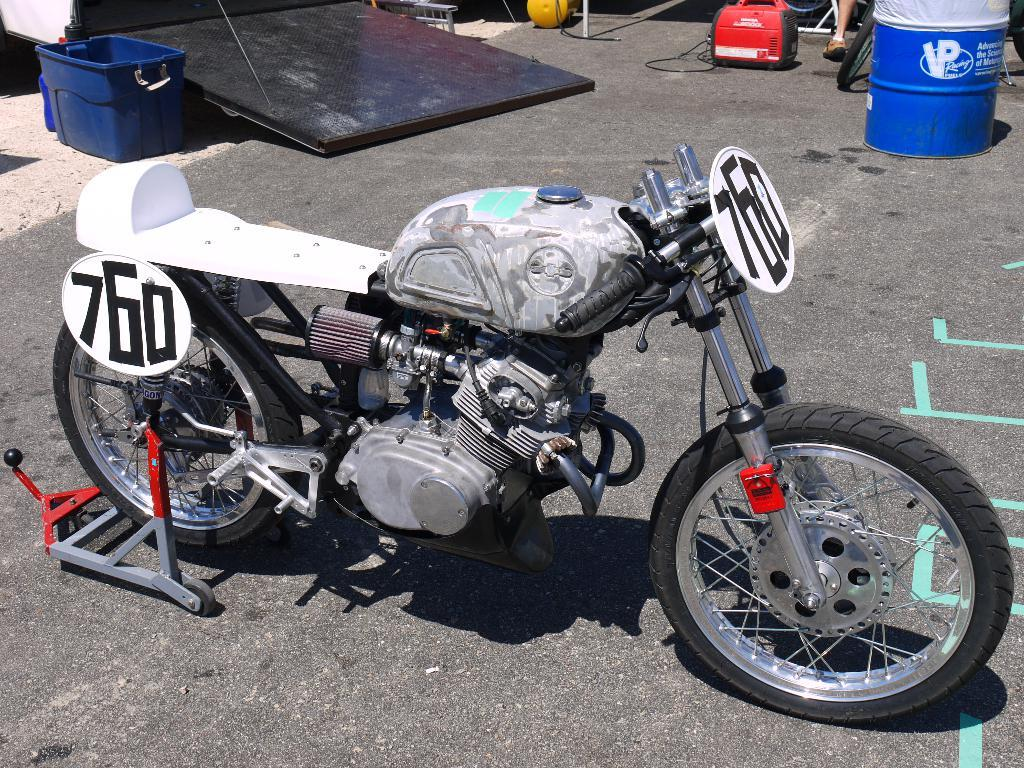What is the main subject of the image? The main subject of the image is a bike. Where is the bike located in the image? The bike is in the middle of the image. What else can be seen on the ground in the image? There are objects on the ground in the image. Where are the objects located in the image? The objects are at the top of the image. What type of map can be seen on the bike in the image? There is no map present on the bike in the image. How many zebras are visible in the image? There are no zebras visible in the image. 